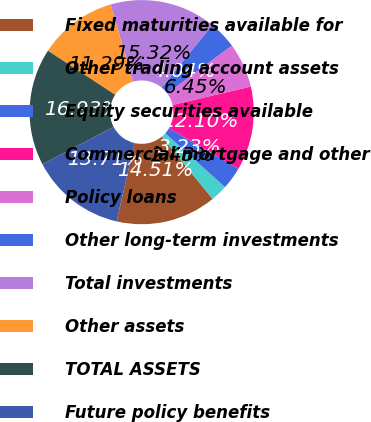<chart> <loc_0><loc_0><loc_500><loc_500><pie_chart><fcel>Fixed maturities available for<fcel>Other trading account assets<fcel>Equity securities available<fcel>Commercial mortgage and other<fcel>Policy loans<fcel>Other long-term investments<fcel>Total investments<fcel>Other assets<fcel>TOTAL ASSETS<fcel>Future policy benefits<nl><fcel>14.51%<fcel>2.43%<fcel>3.23%<fcel>12.1%<fcel>6.45%<fcel>4.04%<fcel>15.32%<fcel>11.29%<fcel>16.93%<fcel>13.71%<nl></chart> 